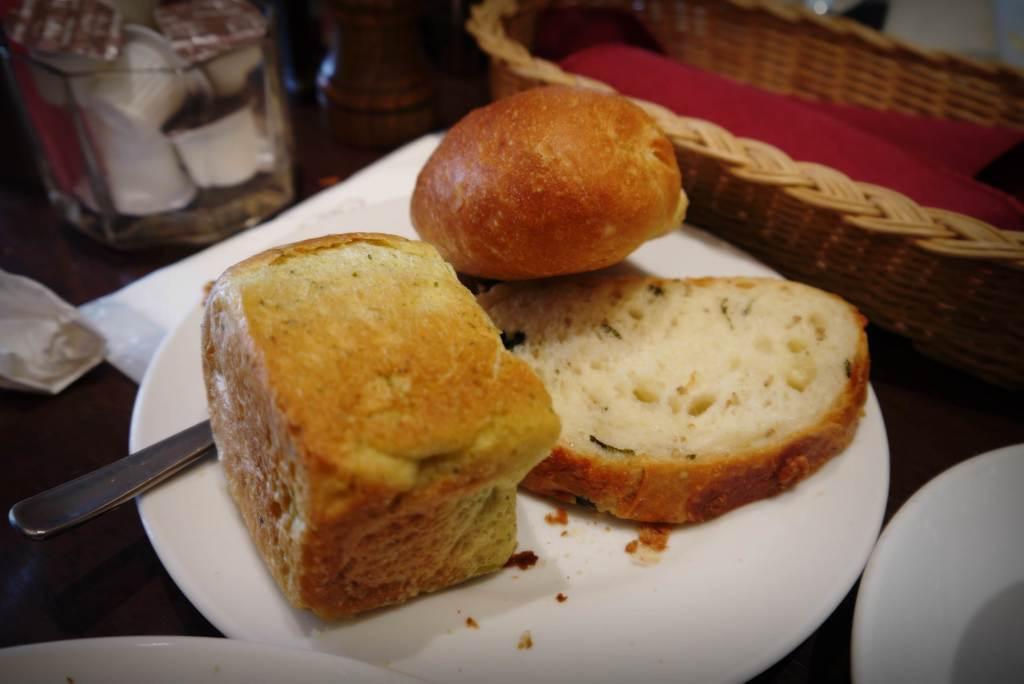How would you summarize this image in a sentence or two? On a plate,there are different types of breads and beside the plate there is a basket and two other plates and a jar. All these are kept on a table. 